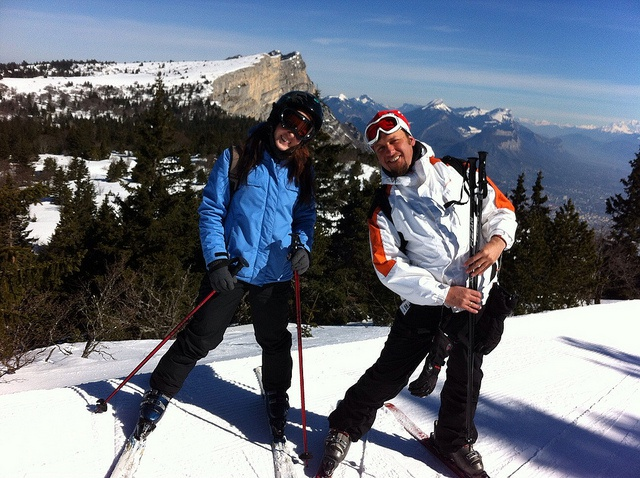Describe the objects in this image and their specific colors. I can see people in gray, black, white, and darkgray tones, people in gray, black, navy, lightblue, and blue tones, skis in gray, lightgray, darkgray, and black tones, and skis in gray, black, lightgray, and darkgray tones in this image. 